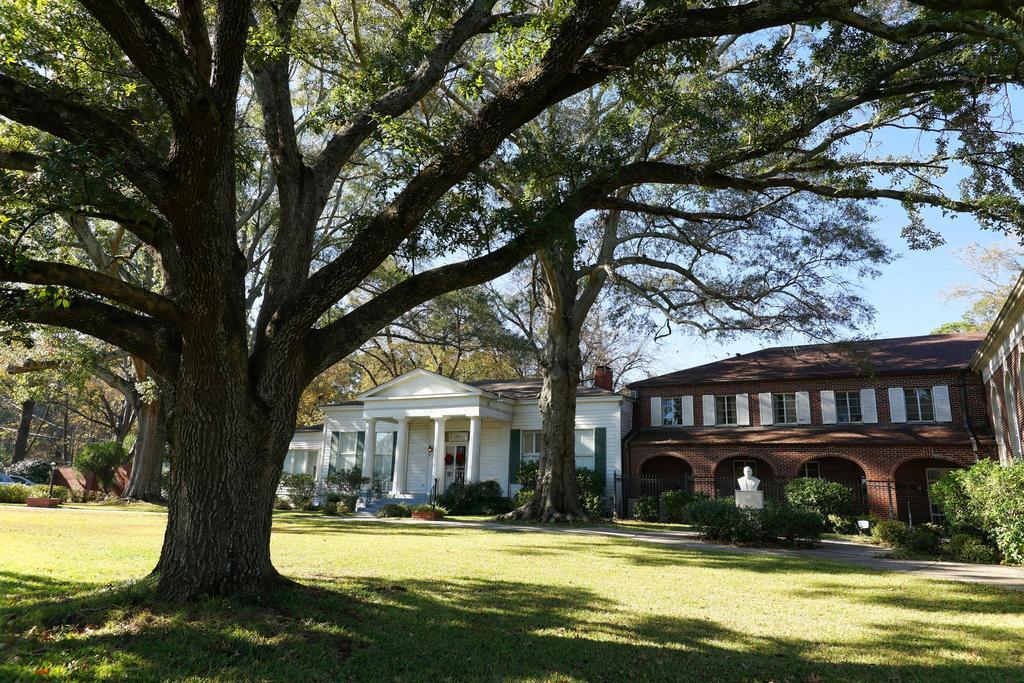How would you summarize this image in a sentence or two? On the left we can see a tree and there's grass on the ground. In the background we can see buildings,windows,doors,statue on a platform,trees and sky. 